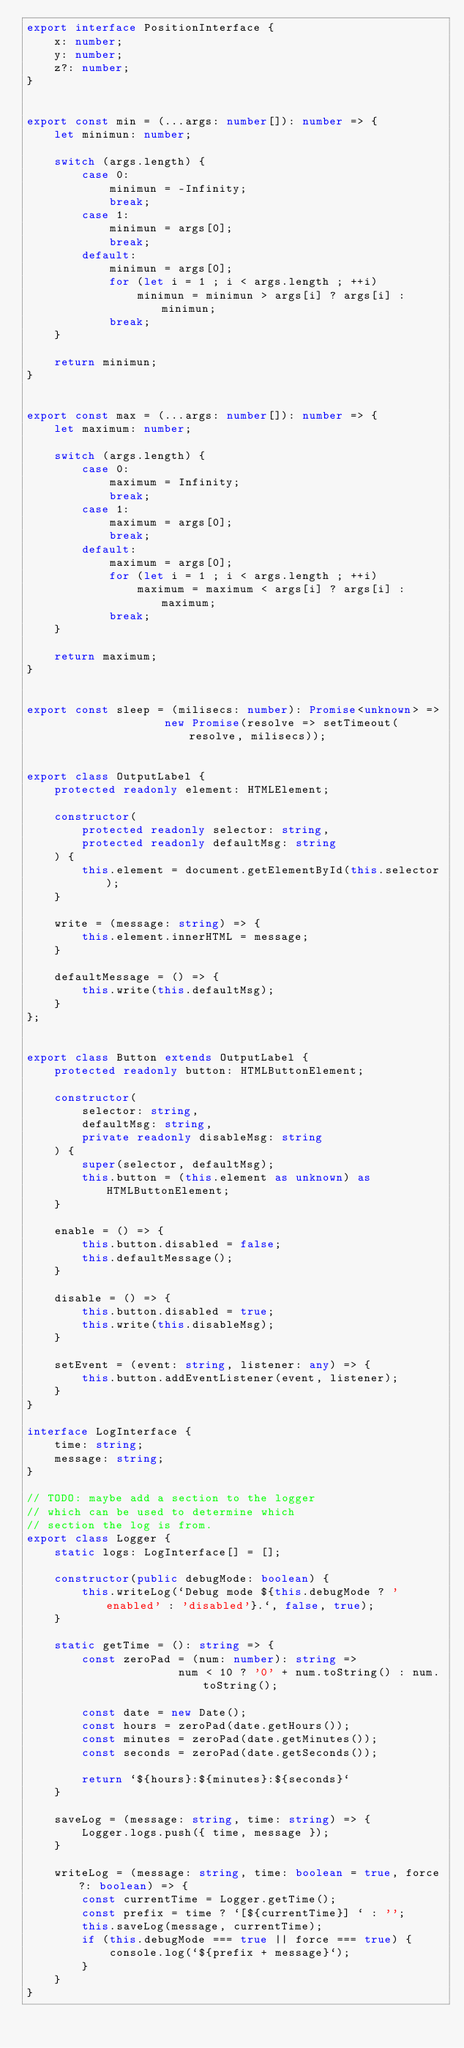<code> <loc_0><loc_0><loc_500><loc_500><_TypeScript_>export interface PositionInterface {
    x: number;
    y: number;
    z?: number;
}


export const min = (...args: number[]): number => {
    let minimun: number;

    switch (args.length) {
        case 0:
            minimun = -Infinity;
            break;
        case 1:
            minimun = args[0];
            break;
        default:
            minimun = args[0];
            for (let i = 1 ; i < args.length ; ++i)
                minimun = minimun > args[i] ? args[i] : minimun;
            break;
    }

    return minimun;
}


export const max = (...args: number[]): number => {
    let maximum: number;

    switch (args.length) {
        case 0:
            maximum = Infinity;
            break;
        case 1:
            maximum = args[0];
            break;
        default:
            maximum = args[0];
            for (let i = 1 ; i < args.length ; ++i)
                maximum = maximum < args[i] ? args[i] : maximum;
            break;
    }

    return maximum;
}


export const sleep = (milisecs: number): Promise<unknown> =>
                    new Promise(resolve => setTimeout(resolve, milisecs));


export class OutputLabel {
    protected readonly element: HTMLElement;

    constructor(
        protected readonly selector: string,
        protected readonly defaultMsg: string
    ) {
        this.element = document.getElementById(this.selector);
    }

    write = (message: string) => {
        this.element.innerHTML = message;
    }

    defaultMessage = () => {
        this.write(this.defaultMsg);
    }
};


export class Button extends OutputLabel {
    protected readonly button: HTMLButtonElement;

    constructor(
        selector: string,
        defaultMsg: string,
        private readonly disableMsg: string
    ) {
        super(selector, defaultMsg);
        this.button = (this.element as unknown) as HTMLButtonElement;
    }

    enable = () => {
        this.button.disabled = false;
        this.defaultMessage();
    }

    disable = () => {
        this.button.disabled = true;
        this.write(this.disableMsg);
    }

    setEvent = (event: string, listener: any) => {
        this.button.addEventListener(event, listener);
    }
}

interface LogInterface {
    time: string;
    message: string;
}

// TODO: maybe add a section to the logger
// which can be used to determine which
// section the log is from.
export class Logger {
    static logs: LogInterface[] = [];

    constructor(public debugMode: boolean) {
        this.writeLog(`Debug mode ${this.debugMode ? 'enabled' : 'disabled'}.`, false, true);
    }

    static getTime = (): string => {
        const zeroPad = (num: number): string =>  
                      num < 10 ? '0' + num.toString() : num.toString();

        const date = new Date();
        const hours = zeroPad(date.getHours());
        const minutes = zeroPad(date.getMinutes());
        const seconds = zeroPad(date.getSeconds());

        return `${hours}:${minutes}:${seconds}`
    }

    saveLog = (message: string, time: string) => {
        Logger.logs.push({ time, message });
    }

    writeLog = (message: string, time: boolean = true, force?: boolean) => {
        const currentTime = Logger.getTime();
        const prefix = time ? `[${currentTime}] ` : '';
        this.saveLog(message, currentTime);
        if (this.debugMode === true || force === true) {
            console.log(`${prefix + message}`);
        }
    }   
}
</code> 